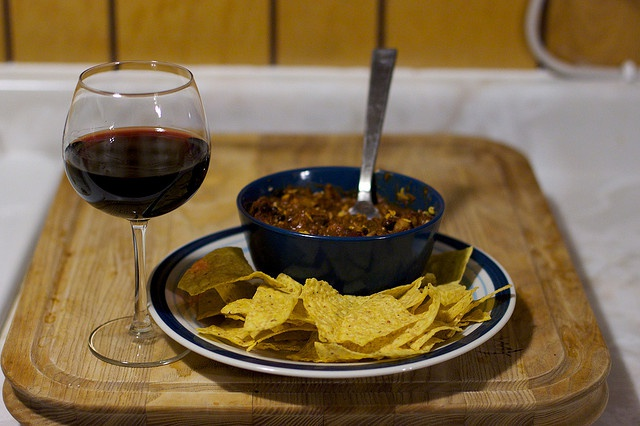Describe the objects in this image and their specific colors. I can see wine glass in olive, black, darkgray, tan, and gray tones, bowl in olive, black, maroon, and navy tones, and spoon in olive, gray, and black tones in this image. 